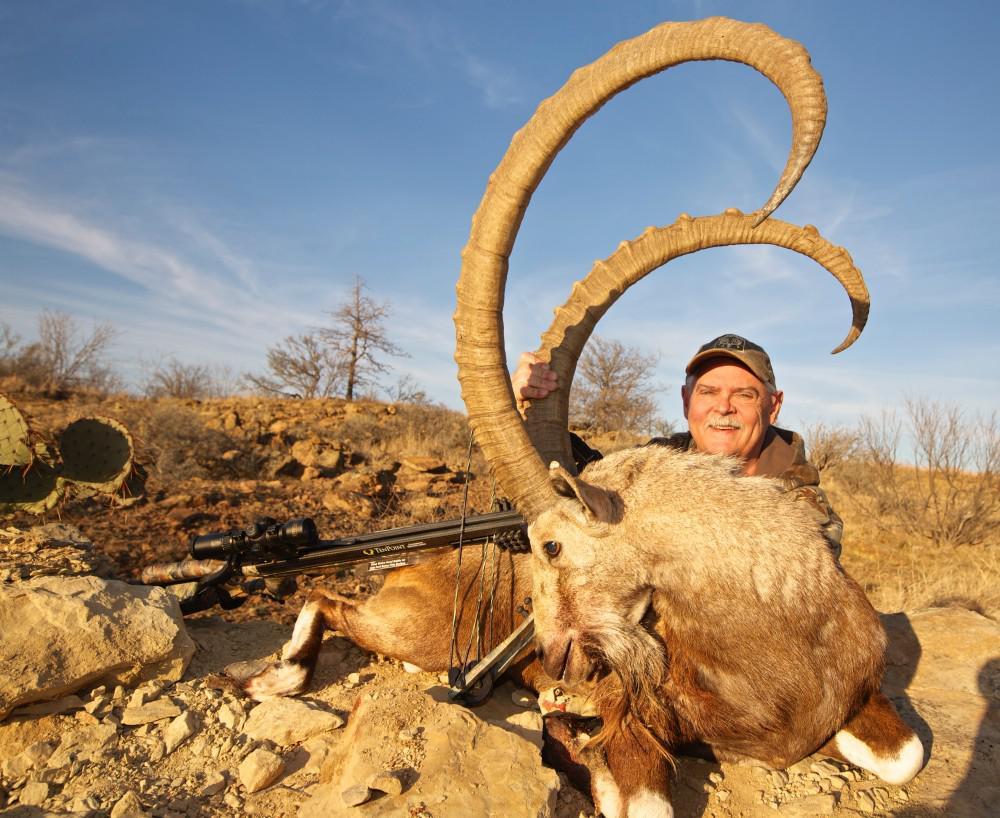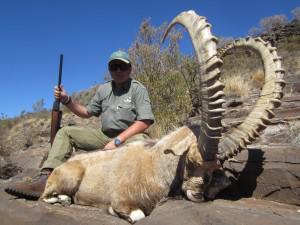The first image is the image on the left, the second image is the image on the right. Considering the images on both sides, is "The hunter is near his gun in the image on the right." valid? Answer yes or no. Yes. The first image is the image on the left, the second image is the image on the right. Examine the images to the left and right. Is the description "An image shows a person in a hat and camo-patterned top posed next to a long-horned animal." accurate? Answer yes or no. No. 